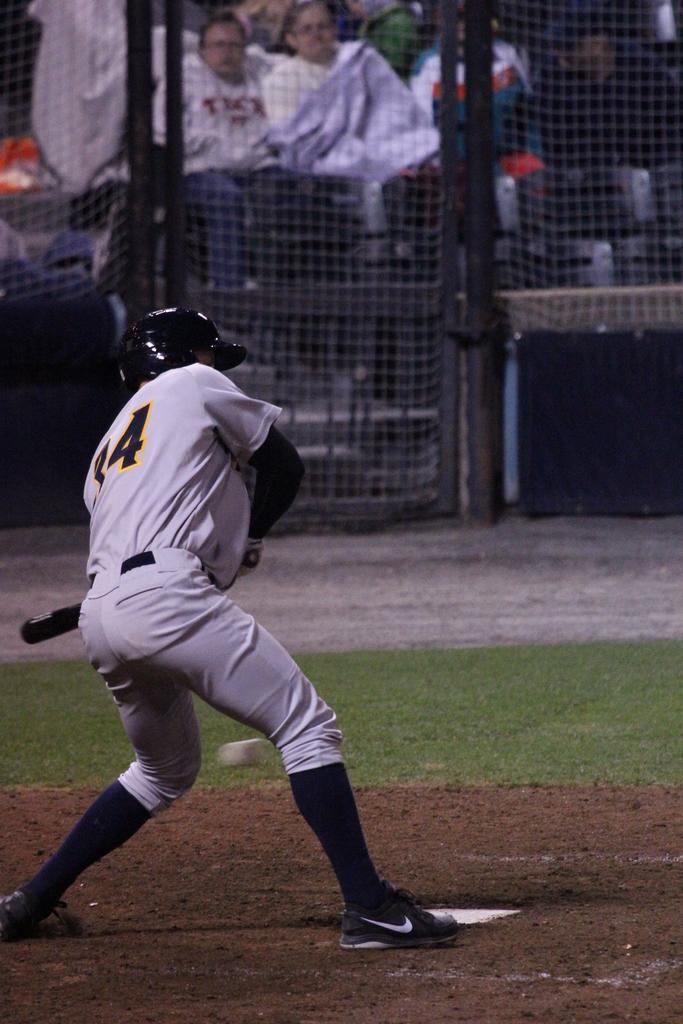Could you give a brief overview of what you see in this image? In the center of the image we can see person holding bat and standing on the ground. In the background we can see fencing and persons. 